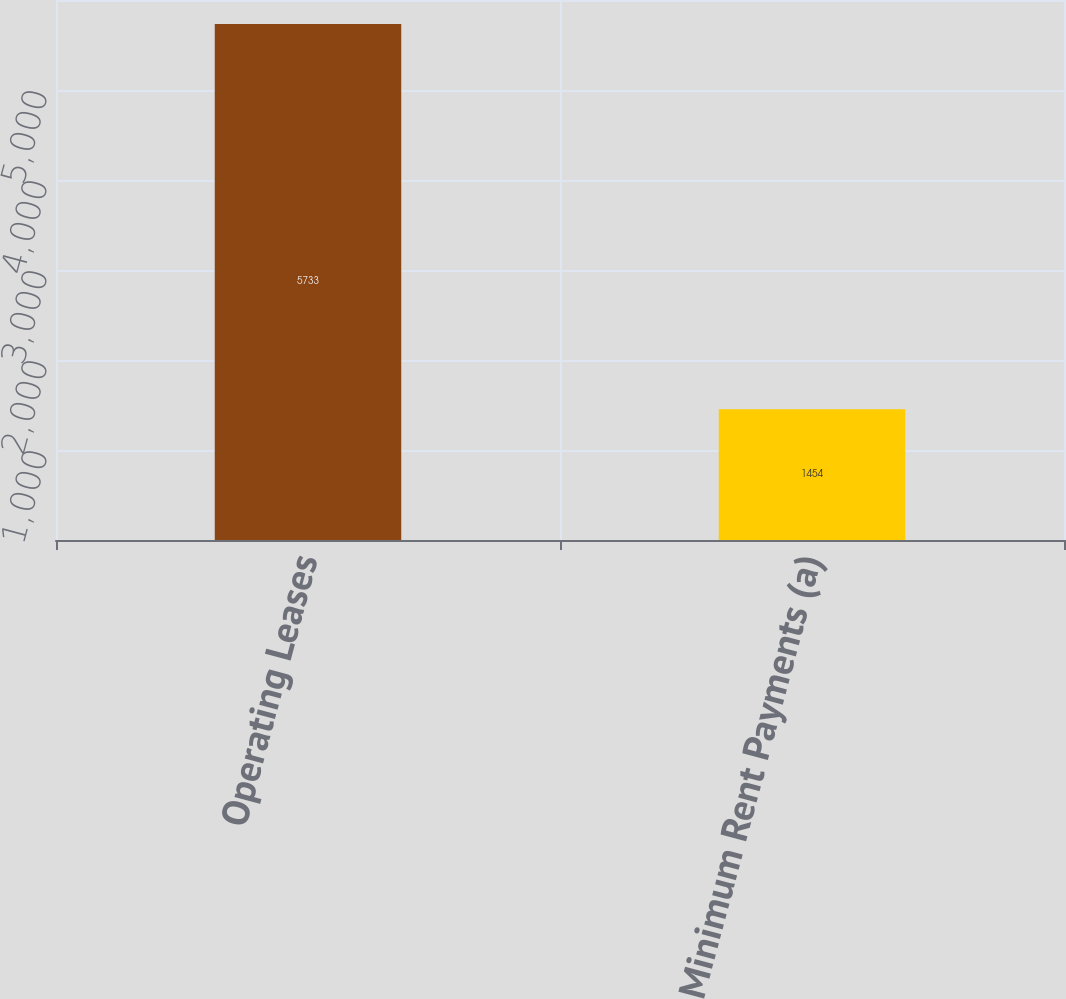<chart> <loc_0><loc_0><loc_500><loc_500><bar_chart><fcel>Operating Leases<fcel>Minimum Rent Payments (a)<nl><fcel>5733<fcel>1454<nl></chart> 